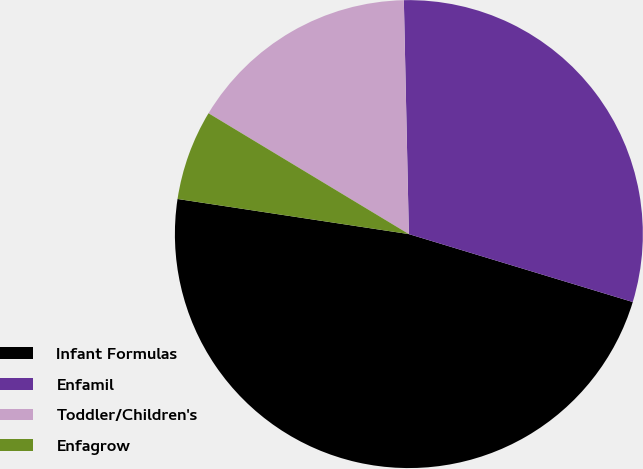Convert chart to OTSL. <chart><loc_0><loc_0><loc_500><loc_500><pie_chart><fcel>Infant Formulas<fcel>Enfamil<fcel>Toddler/Children's<fcel>Enfagrow<nl><fcel>47.71%<fcel>30.03%<fcel>16.02%<fcel>6.24%<nl></chart> 